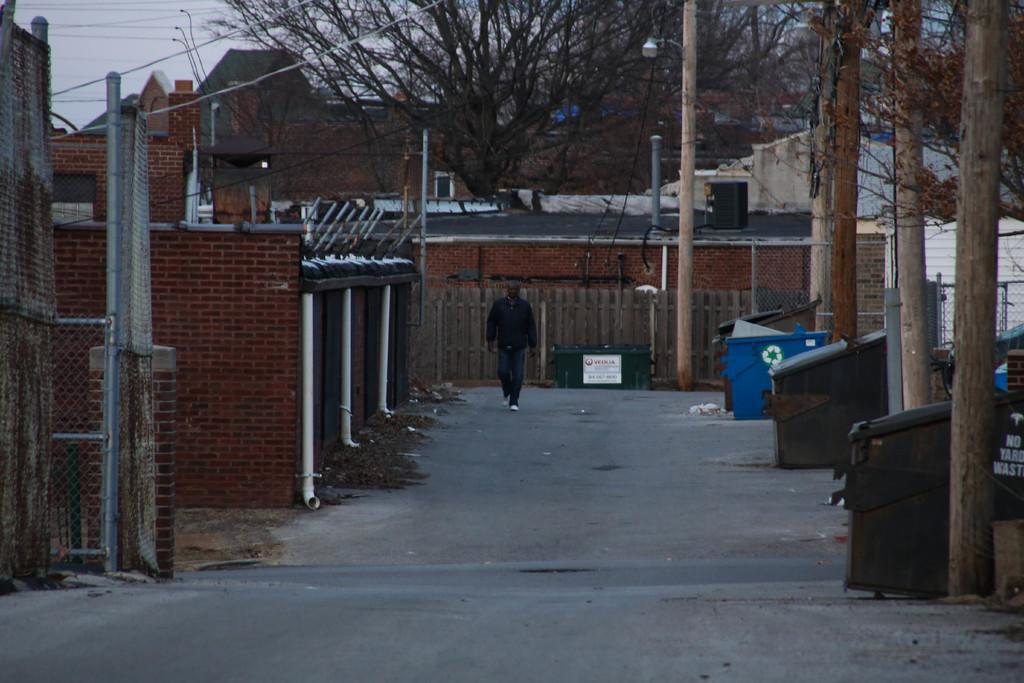In one or two sentences, can you explain what this image depicts? In this we can see a man is walking on the path and on the right side of the man there are dustbins and tree trunks. Behind the man there is a wooden fence, buildings, trees, cables and the sky. 